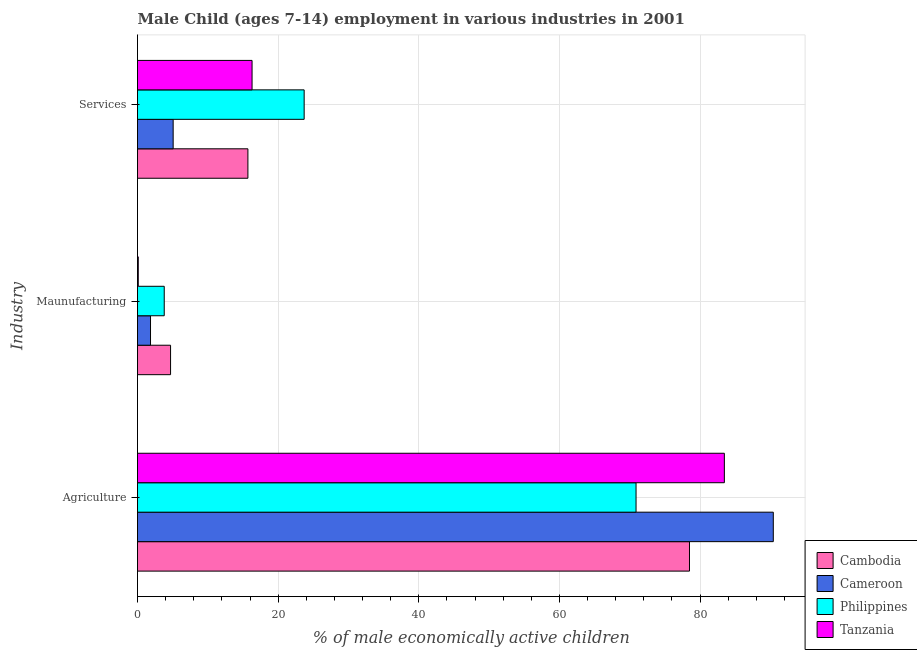Are the number of bars on each tick of the Y-axis equal?
Keep it short and to the point. Yes. What is the label of the 2nd group of bars from the top?
Offer a terse response. Maunufacturing. What is the percentage of economically active children in services in Cameroon?
Ensure brevity in your answer.  5.07. Across all countries, what is the minimum percentage of economically active children in agriculture?
Make the answer very short. 70.9. In which country was the percentage of economically active children in services maximum?
Provide a succinct answer. Philippines. In which country was the percentage of economically active children in manufacturing minimum?
Keep it short and to the point. Tanzania. What is the total percentage of economically active children in agriculture in the graph?
Offer a very short reply. 323.28. What is the difference between the percentage of economically active children in agriculture in Cameroon and the percentage of economically active children in services in Tanzania?
Your response must be concise. 74.13. What is the average percentage of economically active children in manufacturing per country?
Offer a terse response. 2.61. What is the difference between the percentage of economically active children in services and percentage of economically active children in agriculture in Philippines?
Give a very brief answer. -47.2. In how many countries, is the percentage of economically active children in services greater than 44 %?
Offer a very short reply. 0. What is the ratio of the percentage of economically active children in manufacturing in Cambodia to that in Cameroon?
Your answer should be very brief. 2.54. Is the percentage of economically active children in agriculture in Tanzania less than that in Philippines?
Give a very brief answer. No. Is the difference between the percentage of economically active children in services in Philippines and Cameroon greater than the difference between the percentage of economically active children in manufacturing in Philippines and Cameroon?
Give a very brief answer. Yes. What is the difference between the highest and the second highest percentage of economically active children in agriculture?
Make the answer very short. 6.96. What is the difference between the highest and the lowest percentage of economically active children in agriculture?
Keep it short and to the point. 19.52. Is the sum of the percentage of economically active children in manufacturing in Cambodia and Tanzania greater than the maximum percentage of economically active children in services across all countries?
Give a very brief answer. No. What does the 2nd bar from the top in Services represents?
Give a very brief answer. Philippines. What does the 1st bar from the bottom in Services represents?
Make the answer very short. Cambodia. How many bars are there?
Give a very brief answer. 12. Are all the bars in the graph horizontal?
Offer a terse response. Yes. How many countries are there in the graph?
Make the answer very short. 4. What is the difference between two consecutive major ticks on the X-axis?
Your answer should be compact. 20. Are the values on the major ticks of X-axis written in scientific E-notation?
Your answer should be very brief. No. Does the graph contain any zero values?
Keep it short and to the point. No. Does the graph contain grids?
Make the answer very short. Yes. Where does the legend appear in the graph?
Offer a terse response. Bottom right. What is the title of the graph?
Give a very brief answer. Male Child (ages 7-14) employment in various industries in 2001. Does "New Caledonia" appear as one of the legend labels in the graph?
Ensure brevity in your answer.  No. What is the label or title of the X-axis?
Keep it short and to the point. % of male economically active children. What is the label or title of the Y-axis?
Your answer should be compact. Industry. What is the % of male economically active children in Cambodia in Agriculture?
Ensure brevity in your answer.  78.5. What is the % of male economically active children of Cameroon in Agriculture?
Offer a very short reply. 90.42. What is the % of male economically active children in Philippines in Agriculture?
Offer a terse response. 70.9. What is the % of male economically active children in Tanzania in Agriculture?
Offer a terse response. 83.46. What is the % of male economically active children of Cameroon in Maunufacturing?
Your answer should be compact. 1.85. What is the % of male economically active children in Philippines in Maunufacturing?
Your response must be concise. 3.8. What is the % of male economically active children in Tanzania in Maunufacturing?
Give a very brief answer. 0.11. What is the % of male economically active children of Cameroon in Services?
Your answer should be very brief. 5.07. What is the % of male economically active children in Philippines in Services?
Offer a very short reply. 23.7. What is the % of male economically active children in Tanzania in Services?
Provide a short and direct response. 16.29. Across all Industry, what is the maximum % of male economically active children of Cambodia?
Keep it short and to the point. 78.5. Across all Industry, what is the maximum % of male economically active children of Cameroon?
Your response must be concise. 90.42. Across all Industry, what is the maximum % of male economically active children of Philippines?
Your response must be concise. 70.9. Across all Industry, what is the maximum % of male economically active children of Tanzania?
Make the answer very short. 83.46. Across all Industry, what is the minimum % of male economically active children in Cameroon?
Offer a terse response. 1.85. Across all Industry, what is the minimum % of male economically active children of Tanzania?
Your answer should be compact. 0.11. What is the total % of male economically active children of Cambodia in the graph?
Provide a succinct answer. 98.9. What is the total % of male economically active children in Cameroon in the graph?
Offer a terse response. 97.34. What is the total % of male economically active children of Philippines in the graph?
Provide a short and direct response. 98.4. What is the total % of male economically active children of Tanzania in the graph?
Your answer should be very brief. 99.86. What is the difference between the % of male economically active children in Cambodia in Agriculture and that in Maunufacturing?
Make the answer very short. 73.8. What is the difference between the % of male economically active children in Cameroon in Agriculture and that in Maunufacturing?
Your answer should be very brief. 88.57. What is the difference between the % of male economically active children of Philippines in Agriculture and that in Maunufacturing?
Offer a terse response. 67.1. What is the difference between the % of male economically active children in Tanzania in Agriculture and that in Maunufacturing?
Keep it short and to the point. 83.35. What is the difference between the % of male economically active children of Cambodia in Agriculture and that in Services?
Make the answer very short. 62.8. What is the difference between the % of male economically active children in Cameroon in Agriculture and that in Services?
Give a very brief answer. 85.35. What is the difference between the % of male economically active children of Philippines in Agriculture and that in Services?
Offer a terse response. 47.2. What is the difference between the % of male economically active children in Tanzania in Agriculture and that in Services?
Ensure brevity in your answer.  67.17. What is the difference between the % of male economically active children of Cambodia in Maunufacturing and that in Services?
Provide a succinct answer. -11. What is the difference between the % of male economically active children in Cameroon in Maunufacturing and that in Services?
Offer a terse response. -3.22. What is the difference between the % of male economically active children of Philippines in Maunufacturing and that in Services?
Ensure brevity in your answer.  -19.9. What is the difference between the % of male economically active children in Tanzania in Maunufacturing and that in Services?
Provide a succinct answer. -16.18. What is the difference between the % of male economically active children of Cambodia in Agriculture and the % of male economically active children of Cameroon in Maunufacturing?
Keep it short and to the point. 76.65. What is the difference between the % of male economically active children of Cambodia in Agriculture and the % of male economically active children of Philippines in Maunufacturing?
Your answer should be compact. 74.7. What is the difference between the % of male economically active children of Cambodia in Agriculture and the % of male economically active children of Tanzania in Maunufacturing?
Keep it short and to the point. 78.39. What is the difference between the % of male economically active children of Cameroon in Agriculture and the % of male economically active children of Philippines in Maunufacturing?
Ensure brevity in your answer.  86.62. What is the difference between the % of male economically active children in Cameroon in Agriculture and the % of male economically active children in Tanzania in Maunufacturing?
Offer a terse response. 90.31. What is the difference between the % of male economically active children of Philippines in Agriculture and the % of male economically active children of Tanzania in Maunufacturing?
Ensure brevity in your answer.  70.79. What is the difference between the % of male economically active children of Cambodia in Agriculture and the % of male economically active children of Cameroon in Services?
Provide a short and direct response. 73.43. What is the difference between the % of male economically active children in Cambodia in Agriculture and the % of male economically active children in Philippines in Services?
Make the answer very short. 54.8. What is the difference between the % of male economically active children of Cambodia in Agriculture and the % of male economically active children of Tanzania in Services?
Your answer should be very brief. 62.21. What is the difference between the % of male economically active children in Cameroon in Agriculture and the % of male economically active children in Philippines in Services?
Ensure brevity in your answer.  66.72. What is the difference between the % of male economically active children in Cameroon in Agriculture and the % of male economically active children in Tanzania in Services?
Keep it short and to the point. 74.13. What is the difference between the % of male economically active children of Philippines in Agriculture and the % of male economically active children of Tanzania in Services?
Provide a short and direct response. 54.61. What is the difference between the % of male economically active children of Cambodia in Maunufacturing and the % of male economically active children of Cameroon in Services?
Offer a terse response. -0.37. What is the difference between the % of male economically active children of Cambodia in Maunufacturing and the % of male economically active children of Tanzania in Services?
Ensure brevity in your answer.  -11.59. What is the difference between the % of male economically active children of Cameroon in Maunufacturing and the % of male economically active children of Philippines in Services?
Provide a short and direct response. -21.85. What is the difference between the % of male economically active children of Cameroon in Maunufacturing and the % of male economically active children of Tanzania in Services?
Offer a very short reply. -14.44. What is the difference between the % of male economically active children in Philippines in Maunufacturing and the % of male economically active children in Tanzania in Services?
Offer a very short reply. -12.49. What is the average % of male economically active children of Cambodia per Industry?
Provide a short and direct response. 32.97. What is the average % of male economically active children in Cameroon per Industry?
Keep it short and to the point. 32.45. What is the average % of male economically active children in Philippines per Industry?
Provide a short and direct response. 32.8. What is the average % of male economically active children in Tanzania per Industry?
Your answer should be compact. 33.29. What is the difference between the % of male economically active children of Cambodia and % of male economically active children of Cameroon in Agriculture?
Your answer should be very brief. -11.92. What is the difference between the % of male economically active children in Cambodia and % of male economically active children in Philippines in Agriculture?
Your answer should be very brief. 7.6. What is the difference between the % of male economically active children of Cambodia and % of male economically active children of Tanzania in Agriculture?
Make the answer very short. -4.96. What is the difference between the % of male economically active children of Cameroon and % of male economically active children of Philippines in Agriculture?
Keep it short and to the point. 19.52. What is the difference between the % of male economically active children of Cameroon and % of male economically active children of Tanzania in Agriculture?
Give a very brief answer. 6.96. What is the difference between the % of male economically active children of Philippines and % of male economically active children of Tanzania in Agriculture?
Your answer should be very brief. -12.56. What is the difference between the % of male economically active children in Cambodia and % of male economically active children in Cameroon in Maunufacturing?
Offer a very short reply. 2.85. What is the difference between the % of male economically active children of Cambodia and % of male economically active children of Philippines in Maunufacturing?
Your answer should be very brief. 0.9. What is the difference between the % of male economically active children of Cambodia and % of male economically active children of Tanzania in Maunufacturing?
Provide a short and direct response. 4.59. What is the difference between the % of male economically active children in Cameroon and % of male economically active children in Philippines in Maunufacturing?
Ensure brevity in your answer.  -1.95. What is the difference between the % of male economically active children in Cameroon and % of male economically active children in Tanzania in Maunufacturing?
Provide a succinct answer. 1.74. What is the difference between the % of male economically active children in Philippines and % of male economically active children in Tanzania in Maunufacturing?
Make the answer very short. 3.69. What is the difference between the % of male economically active children of Cambodia and % of male economically active children of Cameroon in Services?
Your response must be concise. 10.63. What is the difference between the % of male economically active children in Cambodia and % of male economically active children in Philippines in Services?
Offer a terse response. -8. What is the difference between the % of male economically active children in Cambodia and % of male economically active children in Tanzania in Services?
Your response must be concise. -0.59. What is the difference between the % of male economically active children of Cameroon and % of male economically active children of Philippines in Services?
Offer a very short reply. -18.63. What is the difference between the % of male economically active children of Cameroon and % of male economically active children of Tanzania in Services?
Offer a terse response. -11.22. What is the difference between the % of male economically active children of Philippines and % of male economically active children of Tanzania in Services?
Give a very brief answer. 7.41. What is the ratio of the % of male economically active children in Cambodia in Agriculture to that in Maunufacturing?
Your answer should be very brief. 16.7. What is the ratio of the % of male economically active children of Cameroon in Agriculture to that in Maunufacturing?
Your answer should be compact. 48.88. What is the ratio of the % of male economically active children in Philippines in Agriculture to that in Maunufacturing?
Your answer should be compact. 18.66. What is the ratio of the % of male economically active children of Tanzania in Agriculture to that in Maunufacturing?
Keep it short and to the point. 776.98. What is the ratio of the % of male economically active children of Cambodia in Agriculture to that in Services?
Keep it short and to the point. 5. What is the ratio of the % of male economically active children of Cameroon in Agriculture to that in Services?
Ensure brevity in your answer.  17.83. What is the ratio of the % of male economically active children in Philippines in Agriculture to that in Services?
Provide a succinct answer. 2.99. What is the ratio of the % of male economically active children of Tanzania in Agriculture to that in Services?
Give a very brief answer. 5.12. What is the ratio of the % of male economically active children in Cambodia in Maunufacturing to that in Services?
Offer a terse response. 0.3. What is the ratio of the % of male economically active children of Cameroon in Maunufacturing to that in Services?
Provide a succinct answer. 0.36. What is the ratio of the % of male economically active children in Philippines in Maunufacturing to that in Services?
Ensure brevity in your answer.  0.16. What is the ratio of the % of male economically active children in Tanzania in Maunufacturing to that in Services?
Provide a succinct answer. 0.01. What is the difference between the highest and the second highest % of male economically active children of Cambodia?
Provide a short and direct response. 62.8. What is the difference between the highest and the second highest % of male economically active children of Cameroon?
Your answer should be compact. 85.35. What is the difference between the highest and the second highest % of male economically active children of Philippines?
Give a very brief answer. 47.2. What is the difference between the highest and the second highest % of male economically active children of Tanzania?
Keep it short and to the point. 67.17. What is the difference between the highest and the lowest % of male economically active children of Cambodia?
Make the answer very short. 73.8. What is the difference between the highest and the lowest % of male economically active children of Cameroon?
Your answer should be very brief. 88.57. What is the difference between the highest and the lowest % of male economically active children in Philippines?
Provide a succinct answer. 67.1. What is the difference between the highest and the lowest % of male economically active children in Tanzania?
Make the answer very short. 83.35. 